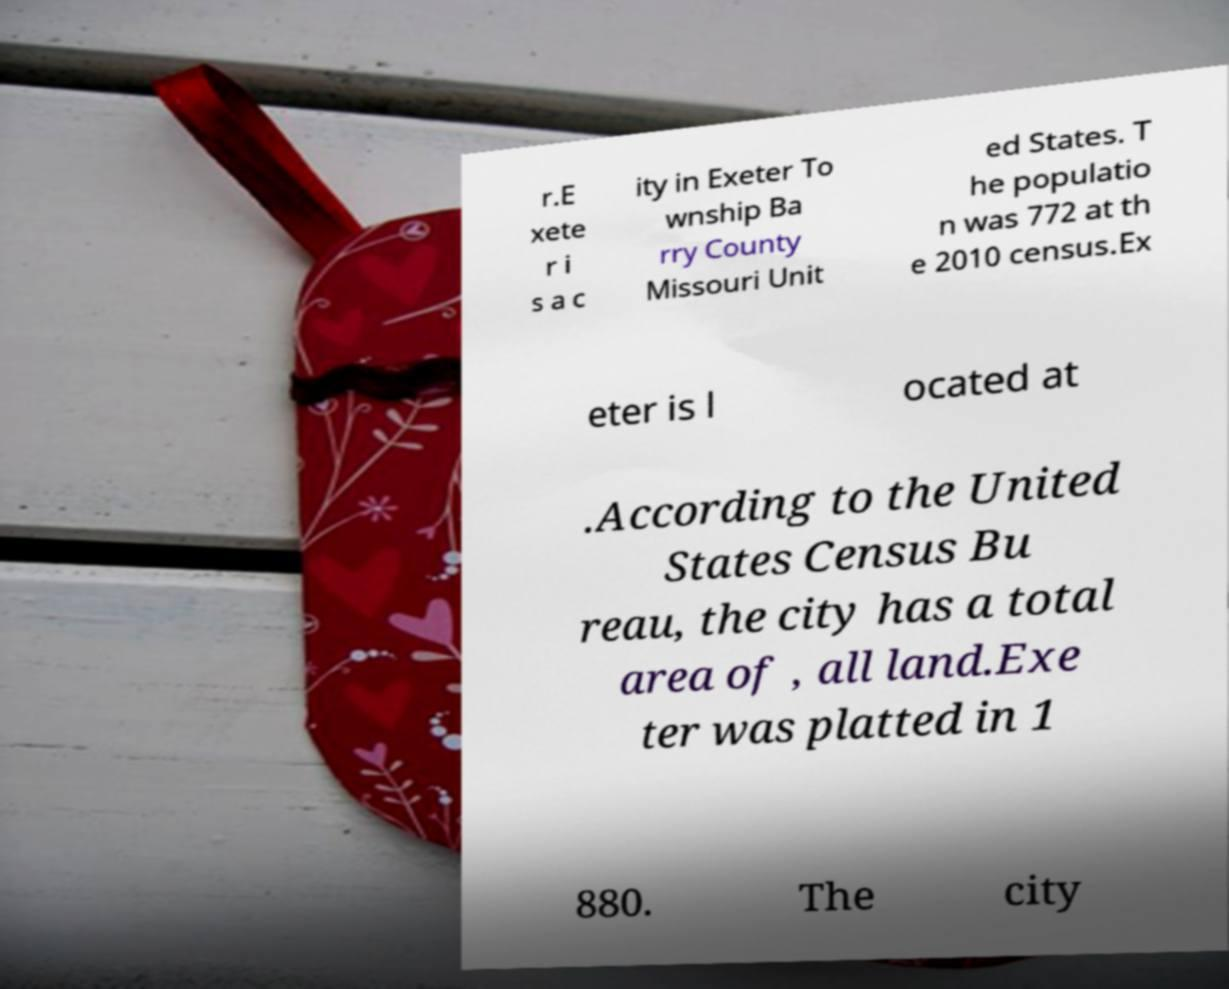What messages or text are displayed in this image? I need them in a readable, typed format. r.E xete r i s a c ity in Exeter To wnship Ba rry County Missouri Unit ed States. T he populatio n was 772 at th e 2010 census.Ex eter is l ocated at .According to the United States Census Bu reau, the city has a total area of , all land.Exe ter was platted in 1 880. The city 